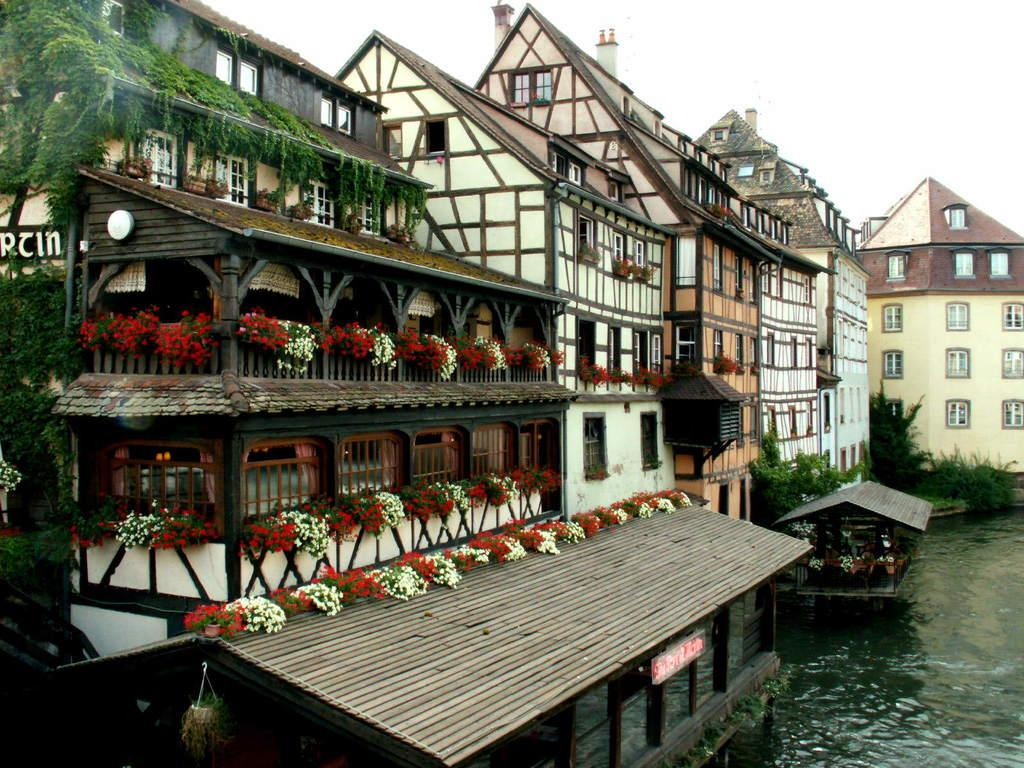What type of structures are present in the image? There are buildings in the image. What other elements can be seen in the image besides the buildings? There are plants in the image. Where are the buildings and plants located in the image? The buildings and plants are in the middle of the image. What can be seen in the bottom right corner of the image? There is water visible in the bottom right corner of the image. What is visible at the top of the image? The sky is visible at the top of the image. What type of flower is growing on the building in the image? There is no flower growing on the building in the image; it only features buildings and plants in the middle of the image. 